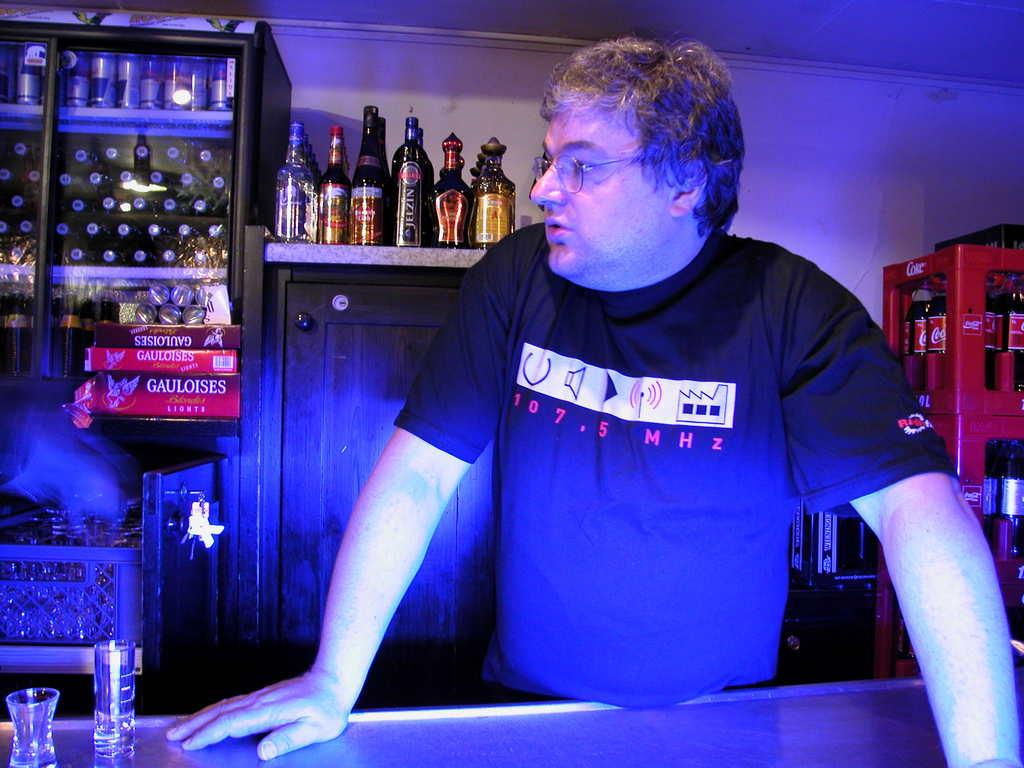<image>
Create a compact narrative representing the image presented. A man wearing a tee shirt with 107.5 MHz radio station printed on it stands behind a bar. 